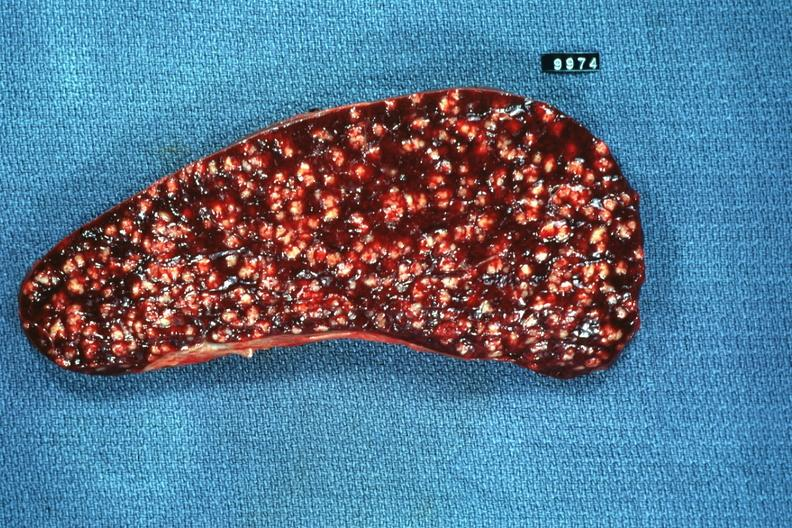where is this part in?
Answer the question using a single word or phrase. Spleen 